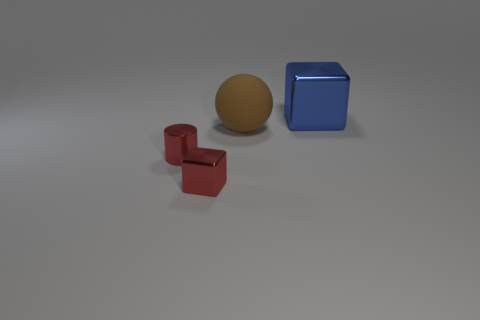Add 2 tiny things. How many objects exist? 6 Subtract all balls. How many objects are left? 3 Subtract 1 blocks. How many blocks are left? 1 Subtract all gray blocks. Subtract all brown spheres. How many blocks are left? 2 Subtract all tiny purple matte spheres. Subtract all small objects. How many objects are left? 2 Add 1 red cylinders. How many red cylinders are left? 2 Add 1 large gray blocks. How many large gray blocks exist? 1 Subtract 0 cyan cubes. How many objects are left? 4 